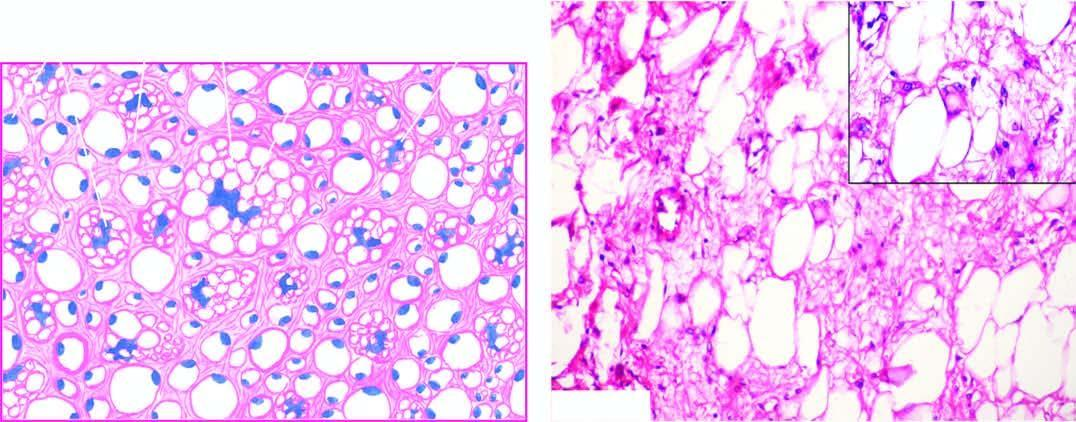does inset in the right photomicrograph show close-up view of a typical lipoblast having multivacuolated cytoplasm indenting the atypical nucleus?
Answer the question using a single word or phrase. Yes 